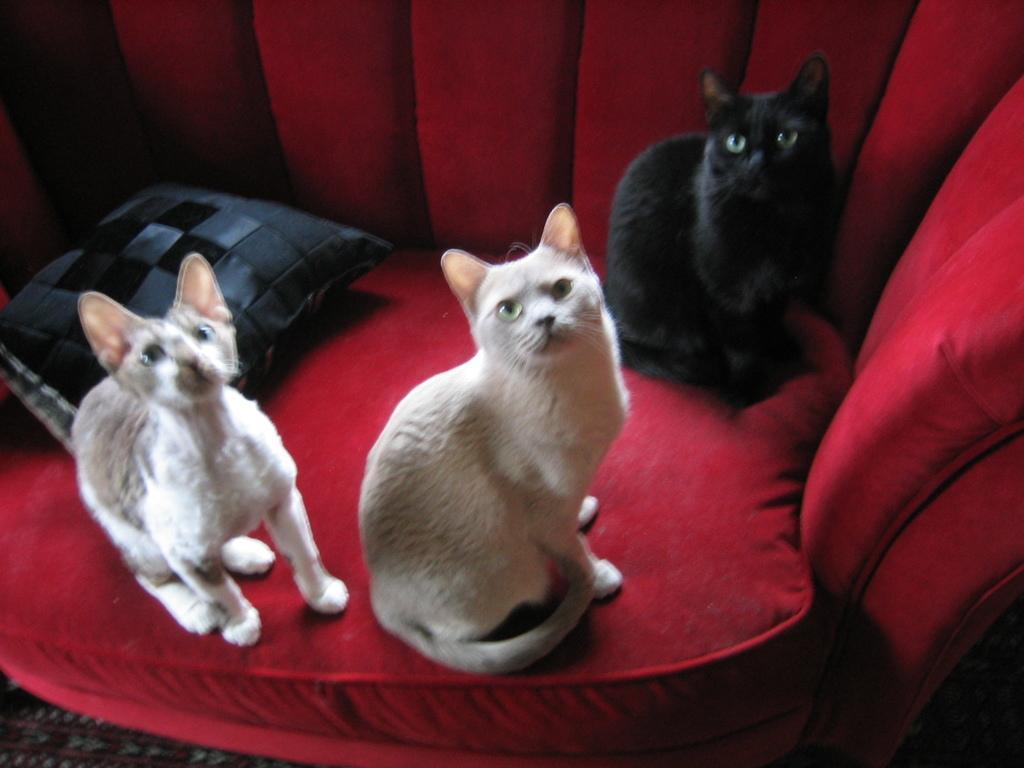Please provide a concise description of this image. In this image I see 3 cats in which these 2 are of white and brown in color and this cat is of black in color and I see that these cats are on the red couch and I see a pillow over here which is of grey and black in color. 